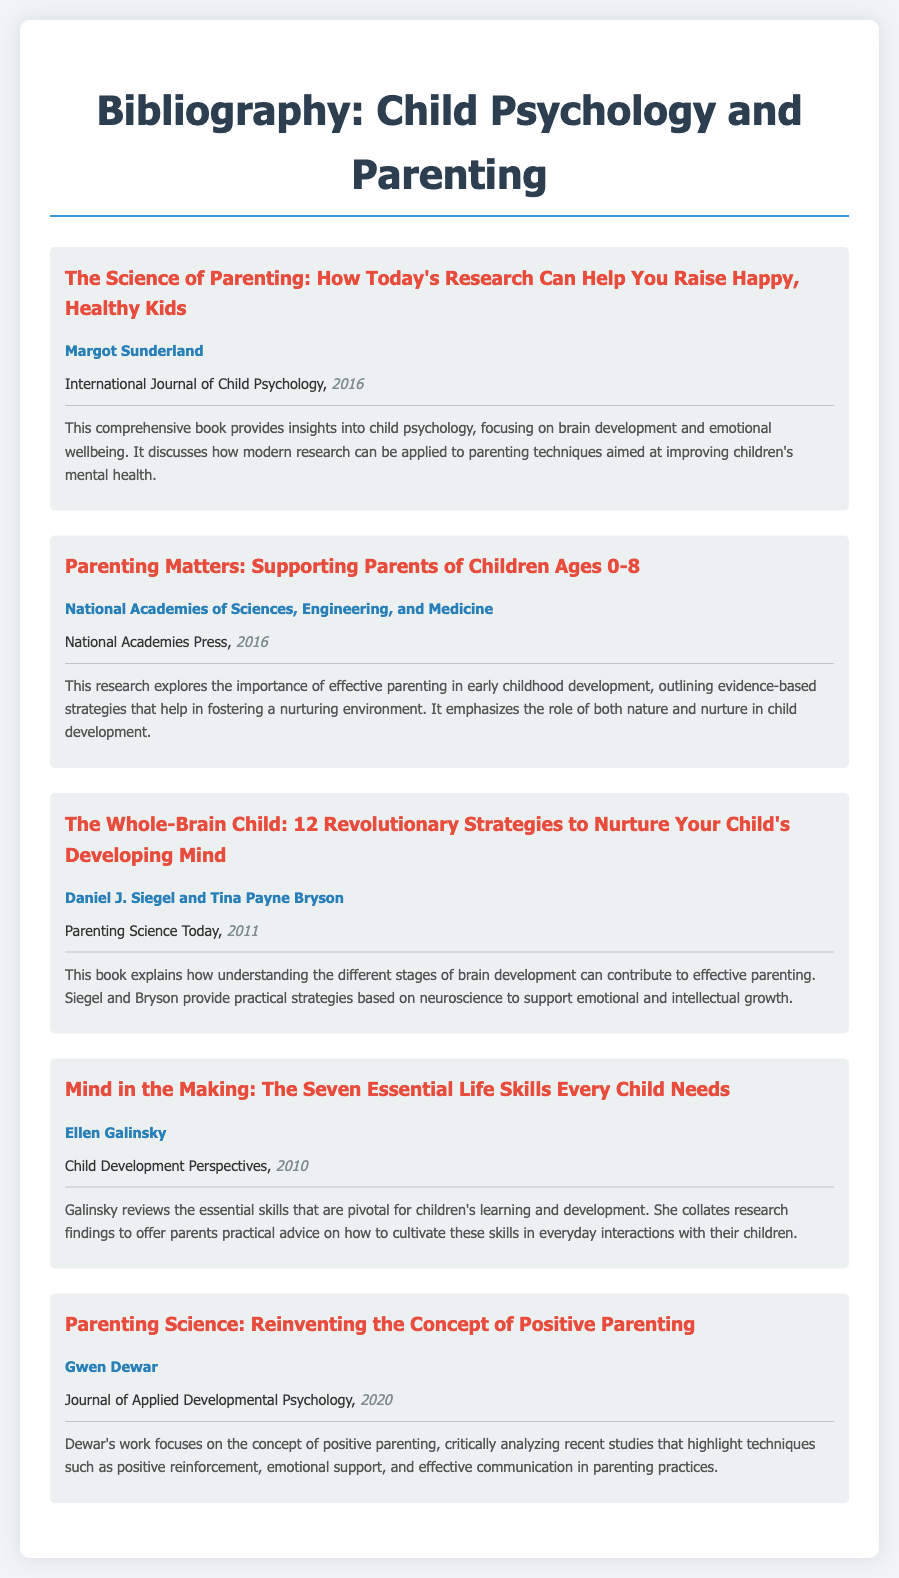what is the title of the first entry? The title of the first entry is mentioned under the heading of the entry section.
Answer: The Science of Parenting: How Today's Research Can Help You Raise Happy, Healthy Kids who is the author of the book published in 2020? The author details are clearly listed below each title, providing information about who wrote what.
Answer: Gwen Dewar which journal published the article by Ellen Galinsky? Each entry includes the name of the journal where the work was published.
Answer: Child Development Perspectives what year was "Parenting Matters" published? The publication year is indicated next to the publisher's name in each entry.
Answer: 2016 how many essential life skills does Ellen Galinsky discuss? The title of Ellen Galinsky's entry gives a clue about the number of skills reviewed.
Answer: Seven what is the main focus of Margot Sunderland's book? The description beneath each title details the central themes and insights of the works.
Answer: brain development and emotional wellbeing which two authors collaborated on "The Whole-Brain Child"? Co-authorship is mentioned in the author section of the entry.
Answer: Daniel J. Siegel and Tina Payne Bryson what concept does Gwen Dewar analyze in her work? The description outlines the central themes or concepts being discussed by the authors.
Answer: positive parenting 